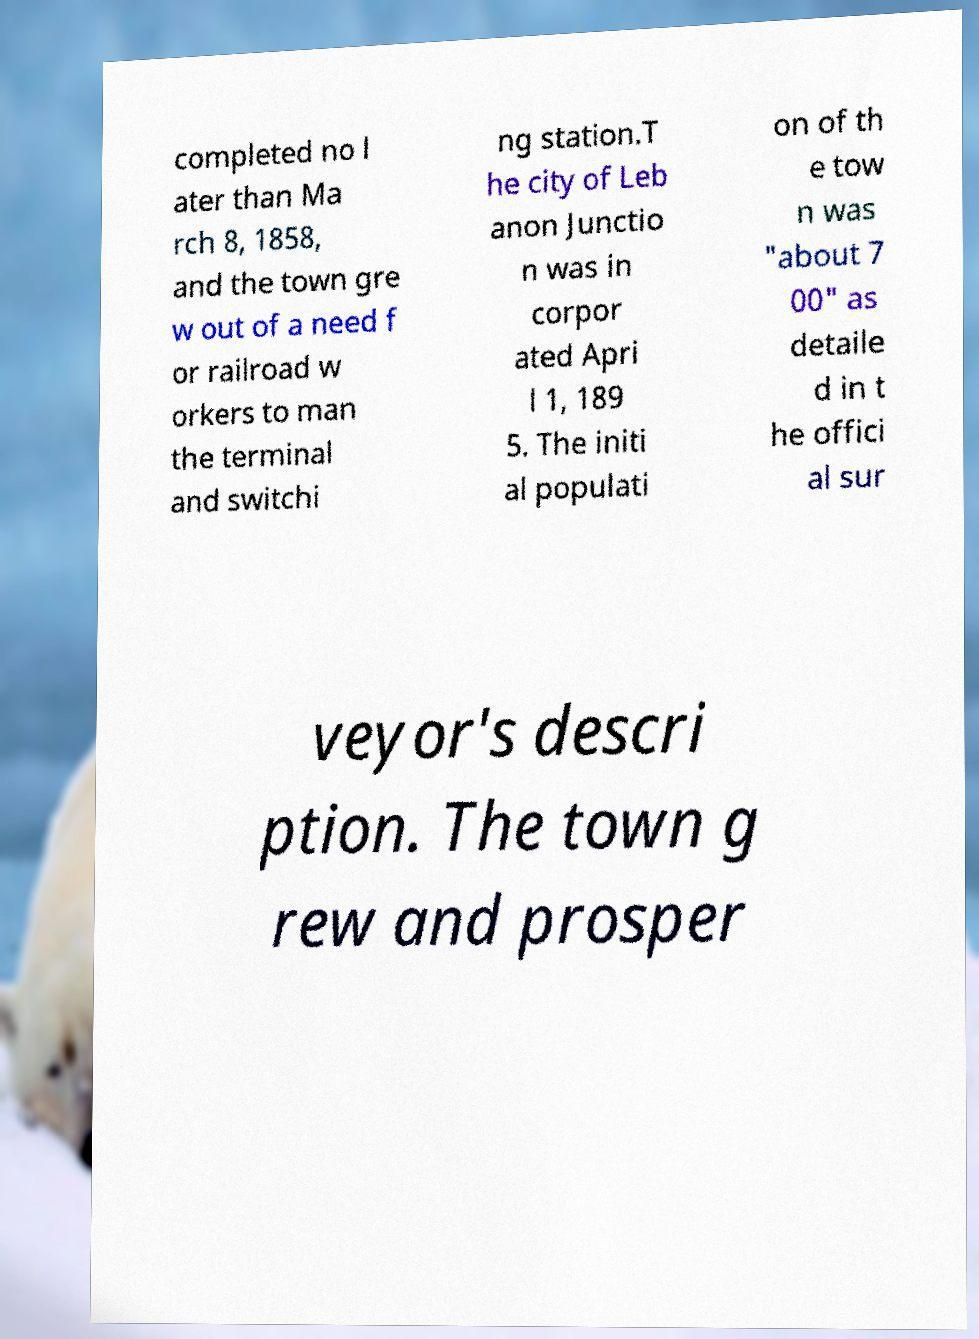Please read and relay the text visible in this image. What does it say? completed no l ater than Ma rch 8, 1858, and the town gre w out of a need f or railroad w orkers to man the terminal and switchi ng station.T he city of Leb anon Junctio n was in corpor ated Apri l 1, 189 5. The initi al populati on of th e tow n was "about 7 00" as detaile d in t he offici al sur veyor's descri ption. The town g rew and prosper 